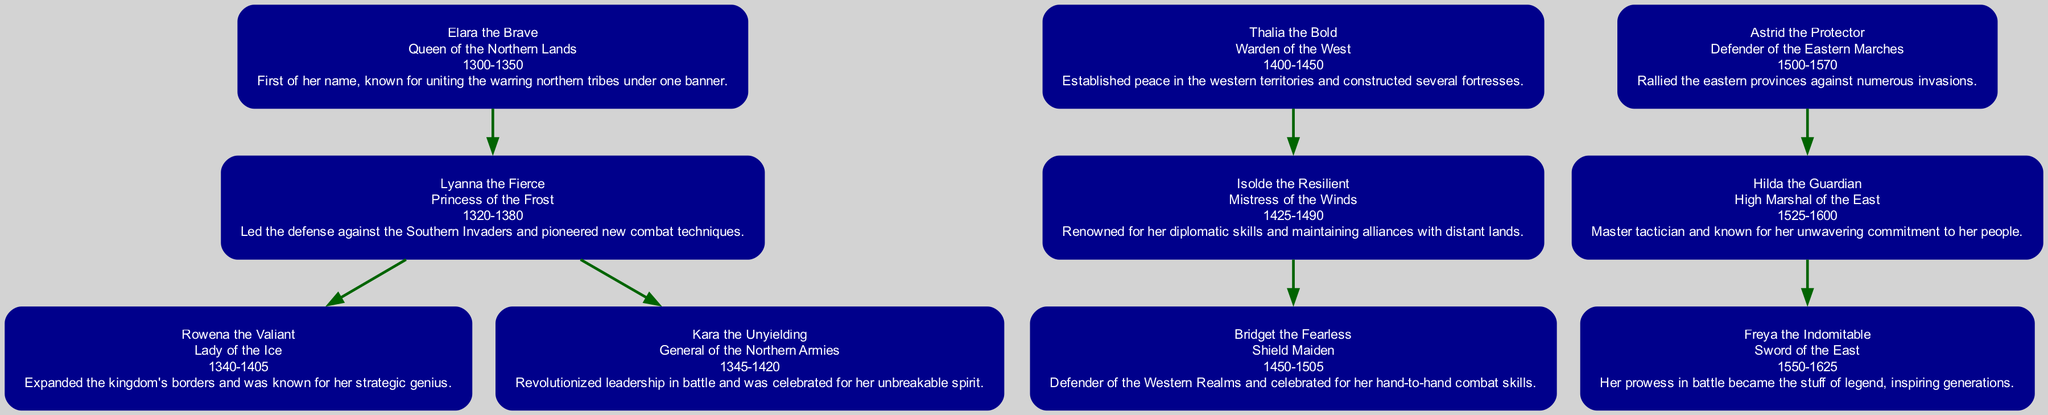What is the title of Elara the Brave? The title of Elara the Brave can be found directly in her section of the diagram, which states her name followed by her title.
Answer: Queen of the Northern Lands How many children does Thalia the Bold have? By reviewing Thalia the Bold’s section in the diagram, we see that she has one child listed, Isolde the Resilient.
Answer: 1 Who are the children of Lyanna the Fierce? The diagram indicates that Lyanna the Fierce has two children listed directly below her name: Rowena the Valiant and Kara the Unyielding.
Answer: Rowena the Valiant and Kara the Unyielding What years did Hilda the Guardian live? The years of Hilda the Guardian’s life are presented in her section of the diagram, denoted right beneath her name along with her title.
Answer: 1525-1600 Which warrior is known for diplomatic skills? By examining the descriptions of the warriors in the diagram, we can identify that Isolde the Resilient is specifically noted for her diplomatic skills.
Answer: Isolde the Resilient Who is the granddaughter of Elara the Brave? To find the granddaughter of Elara the Brave, we look at her child, Lyanna the Fierce, and then her children, Rowena the Valiant and Kara the Unyielding, making them Elara's grandchildren.
Answer: Rowena the Valiant and Kara the Unyielding What title did Freya the Indomitable hold? The title of Freya the Indomitable can be found in her section of the diagram, which clearly states her name followed by her title.
Answer: Sword of the East How many generations are represented in the lineage? By analyzing the structure of the diagram, we can see three distinct generations: Elara the Brave as the first, her children as the second, and her grandchildren as the third.
Answer: 3 What is the primary accomplishment of Thalia the Bold? The description associated with Thalia the Bold in the diagram mentions her establishment of peace and construction of fortresses, summarizing her primary accomplishment.
Answer: Established peace in the western territories Who is the mother of Bridget the Fearless? To find the mother of Bridget the Fearless, we trace back to her parent, which is Isolde the Resilient, as indicated in the diagram.
Answer: Isolde the Resilient 